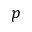<formula> <loc_0><loc_0><loc_500><loc_500>p</formula> 